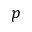<formula> <loc_0><loc_0><loc_500><loc_500>p</formula> 